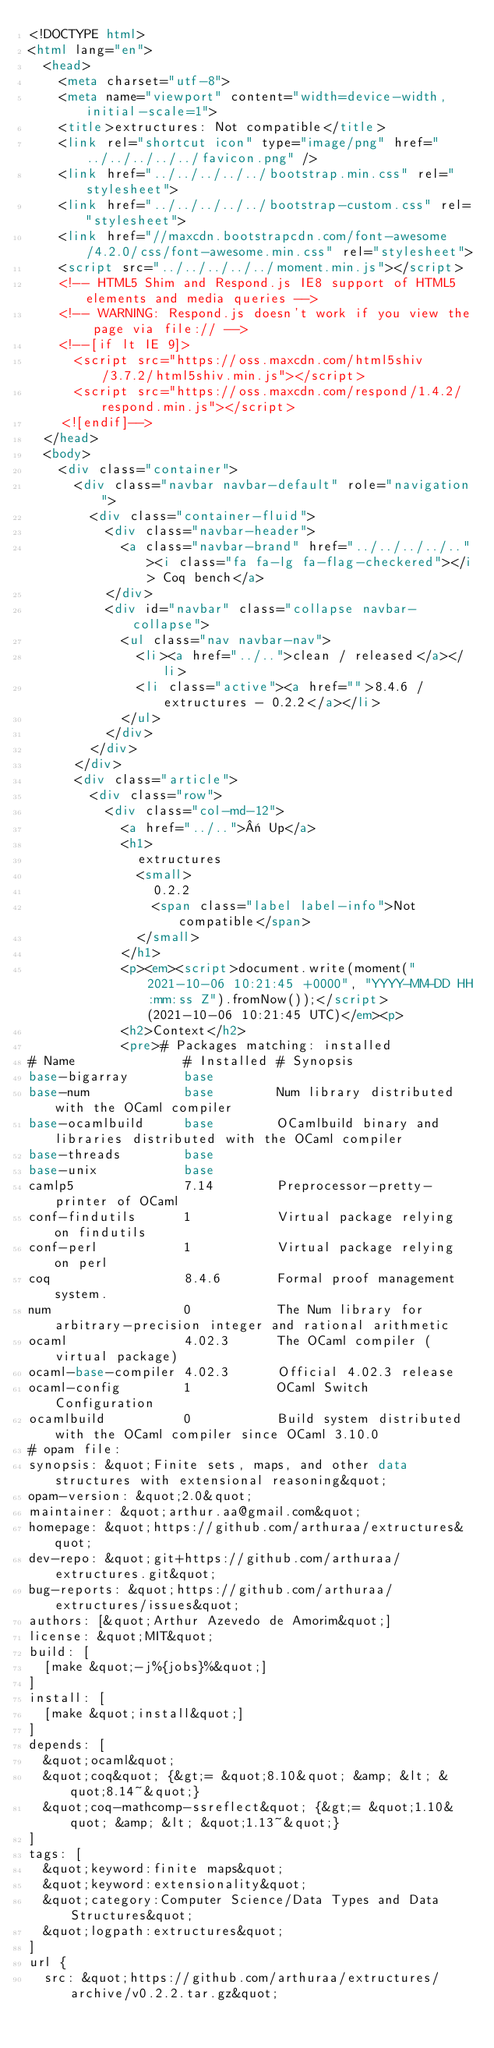<code> <loc_0><loc_0><loc_500><loc_500><_HTML_><!DOCTYPE html>
<html lang="en">
  <head>
    <meta charset="utf-8">
    <meta name="viewport" content="width=device-width, initial-scale=1">
    <title>extructures: Not compatible</title>
    <link rel="shortcut icon" type="image/png" href="../../../../../favicon.png" />
    <link href="../../../../../bootstrap.min.css" rel="stylesheet">
    <link href="../../../../../bootstrap-custom.css" rel="stylesheet">
    <link href="//maxcdn.bootstrapcdn.com/font-awesome/4.2.0/css/font-awesome.min.css" rel="stylesheet">
    <script src="../../../../../moment.min.js"></script>
    <!-- HTML5 Shim and Respond.js IE8 support of HTML5 elements and media queries -->
    <!-- WARNING: Respond.js doesn't work if you view the page via file:// -->
    <!--[if lt IE 9]>
      <script src="https://oss.maxcdn.com/html5shiv/3.7.2/html5shiv.min.js"></script>
      <script src="https://oss.maxcdn.com/respond/1.4.2/respond.min.js"></script>
    <![endif]-->
  </head>
  <body>
    <div class="container">
      <div class="navbar navbar-default" role="navigation">
        <div class="container-fluid">
          <div class="navbar-header">
            <a class="navbar-brand" href="../../../../.."><i class="fa fa-lg fa-flag-checkered"></i> Coq bench</a>
          </div>
          <div id="navbar" class="collapse navbar-collapse">
            <ul class="nav navbar-nav">
              <li><a href="../..">clean / released</a></li>
              <li class="active"><a href="">8.4.6 / extructures - 0.2.2</a></li>
            </ul>
          </div>
        </div>
      </div>
      <div class="article">
        <div class="row">
          <div class="col-md-12">
            <a href="../..">« Up</a>
            <h1>
              extructures
              <small>
                0.2.2
                <span class="label label-info">Not compatible</span>
              </small>
            </h1>
            <p><em><script>document.write(moment("2021-10-06 10:21:45 +0000", "YYYY-MM-DD HH:mm:ss Z").fromNow());</script> (2021-10-06 10:21:45 UTC)</em><p>
            <h2>Context</h2>
            <pre># Packages matching: installed
# Name              # Installed # Synopsis
base-bigarray       base
base-num            base        Num library distributed with the OCaml compiler
base-ocamlbuild     base        OCamlbuild binary and libraries distributed with the OCaml compiler
base-threads        base
base-unix           base
camlp5              7.14        Preprocessor-pretty-printer of OCaml
conf-findutils      1           Virtual package relying on findutils
conf-perl           1           Virtual package relying on perl
coq                 8.4.6       Formal proof management system.
num                 0           The Num library for arbitrary-precision integer and rational arithmetic
ocaml               4.02.3      The OCaml compiler (virtual package)
ocaml-base-compiler 4.02.3      Official 4.02.3 release
ocaml-config        1           OCaml Switch Configuration
ocamlbuild          0           Build system distributed with the OCaml compiler since OCaml 3.10.0
# opam file:
synopsis: &quot;Finite sets, maps, and other data structures with extensional reasoning&quot;
opam-version: &quot;2.0&quot;
maintainer: &quot;arthur.aa@gmail.com&quot;
homepage: &quot;https://github.com/arthuraa/extructures&quot;
dev-repo: &quot;git+https://github.com/arthuraa/extructures.git&quot;
bug-reports: &quot;https://github.com/arthuraa/extructures/issues&quot;
authors: [&quot;Arthur Azevedo de Amorim&quot;]
license: &quot;MIT&quot;
build: [
  [make &quot;-j%{jobs}%&quot;]
]
install: [
  [make &quot;install&quot;]
]
depends: [
  &quot;ocaml&quot;
  &quot;coq&quot; {&gt;= &quot;8.10&quot; &amp; &lt; &quot;8.14~&quot;}
  &quot;coq-mathcomp-ssreflect&quot; {&gt;= &quot;1.10&quot; &amp; &lt; &quot;1.13~&quot;}
]
tags: [
  &quot;keyword:finite maps&quot;
  &quot;keyword:extensionality&quot;
  &quot;category:Computer Science/Data Types and Data Structures&quot;
  &quot;logpath:extructures&quot;
]
url {
  src: &quot;https://github.com/arthuraa/extructures/archive/v0.2.2.tar.gz&quot;</code> 